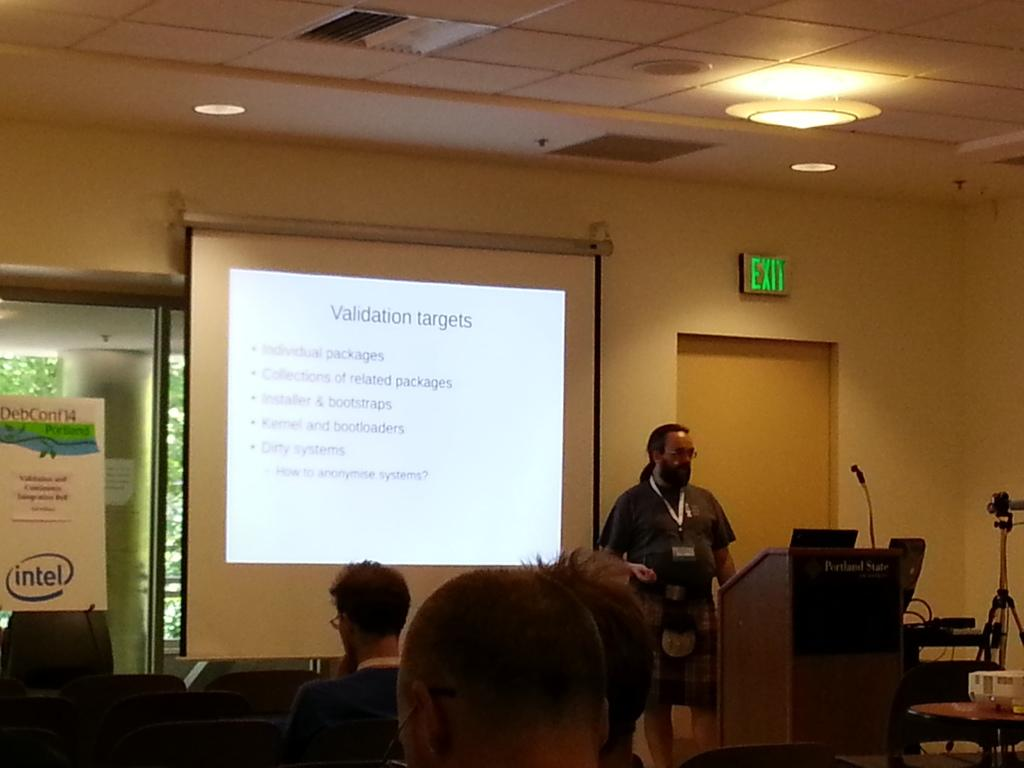What is the man in the image doing? The man is standing in the image. What object can be seen in front of the man? There is a podium in the image. What electronic device is visible in the image? There is a laptop in the image. What device is used for amplifying sound in the image? There is a microphone (mic) in the image. What device is used for capturing images or videos in the image? There is a camera in the image. What source of illumination is present in the image? There is a light in the image. What display device is present in the image? There is a screen in the image. What type of printed material is visible in the image? There is a poster in the image. How many people are sitting on chairs in the image? There are three people sitting on chairs in the image. What type of growth can be seen on the laptop in the image? There is no growth visible on the laptop in the image. What question is being asked by the man in the image? The image does not show the man asking a question, so it cannot be determined from the image. 